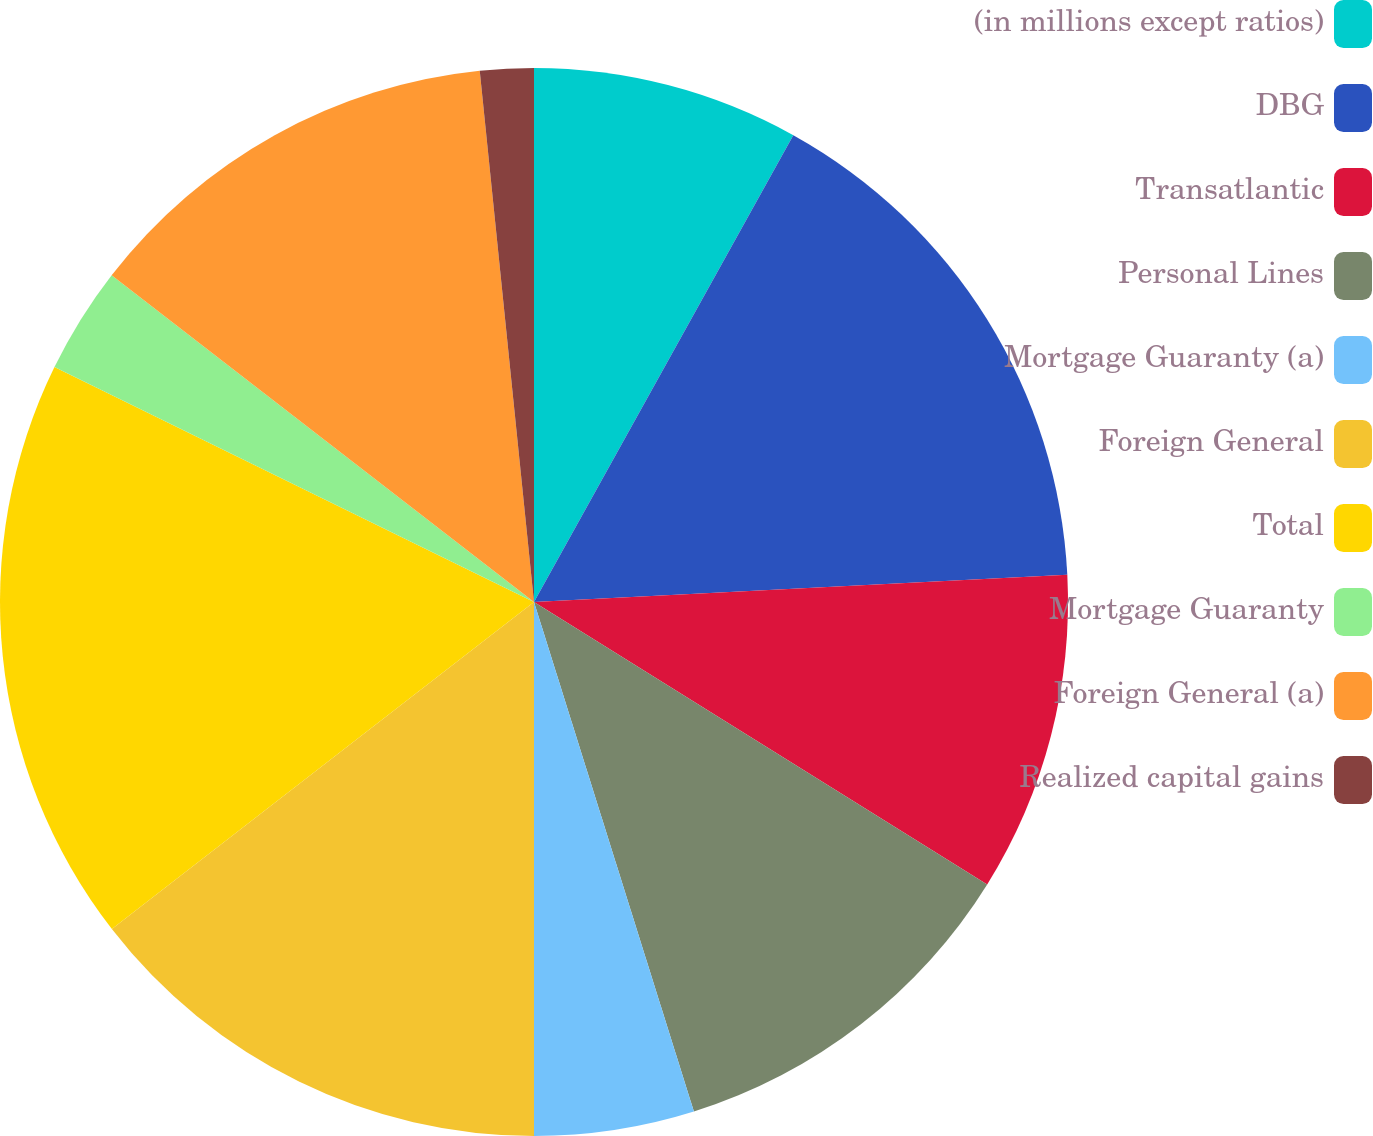<chart> <loc_0><loc_0><loc_500><loc_500><pie_chart><fcel>(in millions except ratios)<fcel>DBG<fcel>Transatlantic<fcel>Personal Lines<fcel>Mortgage Guaranty (a)<fcel>Foreign General<fcel>Total<fcel>Mortgage Guaranty<fcel>Foreign General (a)<fcel>Realized capital gains<nl><fcel>8.07%<fcel>16.12%<fcel>9.68%<fcel>11.29%<fcel>4.84%<fcel>14.51%<fcel>17.74%<fcel>3.23%<fcel>12.9%<fcel>1.62%<nl></chart> 